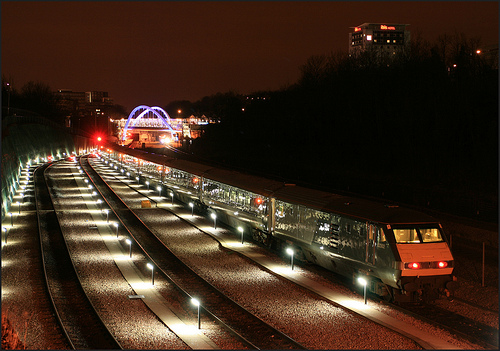What can we infer about the location/settings from this image? The neat arrangement of tracks and overhead lighting suggests an organized and well-maintained railway system, likely part of a city's public transportation infrastructure. The presence of dense foliage on the left and urban structures in the distance hint at a setting on the outskirts of a city. 